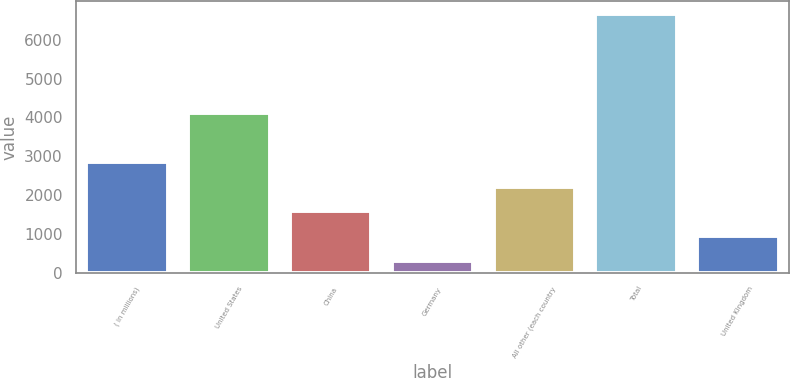<chart> <loc_0><loc_0><loc_500><loc_500><bar_chart><fcel>( in millions)<fcel>United States<fcel>China<fcel>Germany<fcel>All other (each country<fcel>Total<fcel>United Kingdom<nl><fcel>2847.02<fcel>4116.68<fcel>1577.36<fcel>307.7<fcel>2212.19<fcel>6656<fcel>942.53<nl></chart> 